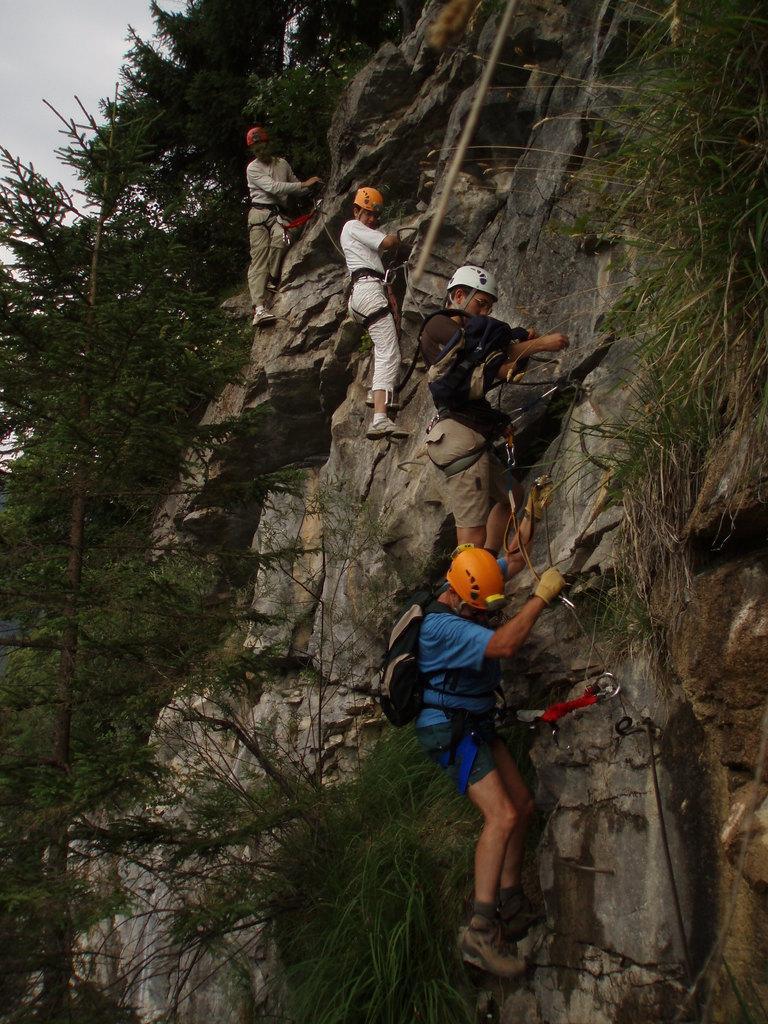Please provide a concise description of this image. In this picture, there is a hill and people climbing the hill. At the bottom, there is a man wearing a blue t shirt and orange helmet. Above him, there is another man wearing black t shirt and white helmet. On the top, there are two men wearing cream and white clothes. The hill is covered with the plants, trees and grass. 